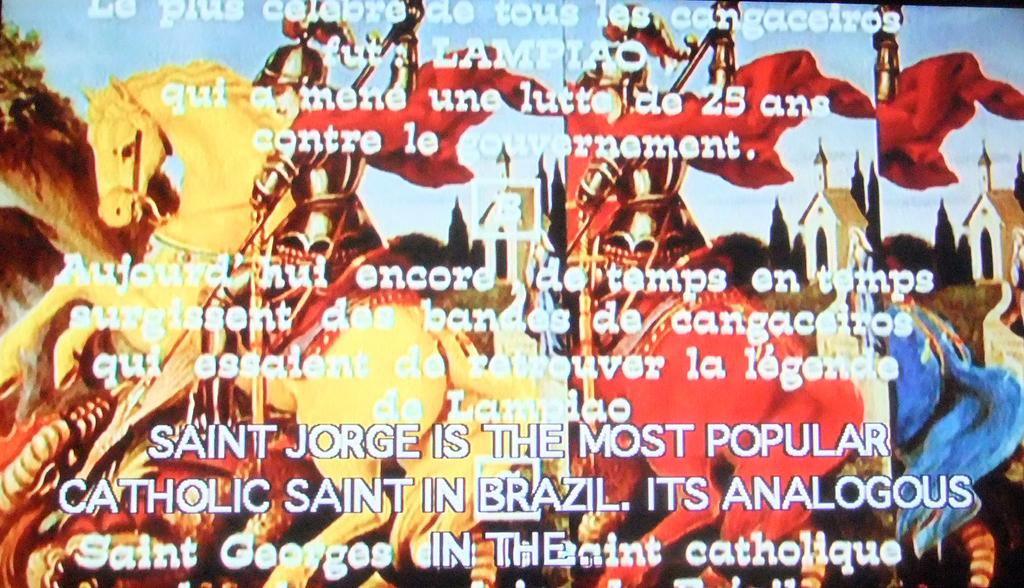<image>
Share a concise interpretation of the image provided. A bright colored page of some sort talkink about Saint George. 